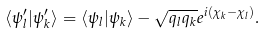Convert formula to latex. <formula><loc_0><loc_0><loc_500><loc_500>\langle \psi _ { l } ^ { \prime } | \psi _ { k } ^ { \prime } \rangle = \langle \psi _ { l } | \psi _ { k } \rangle - \sqrt { q _ { l } q _ { k } } e ^ { i ( \chi _ { k } - \chi _ { l } ) } .</formula> 